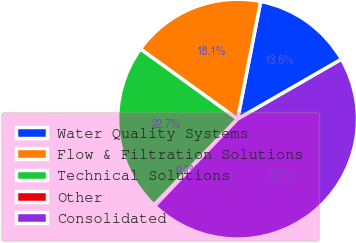<chart> <loc_0><loc_0><loc_500><loc_500><pie_chart><fcel>Water Quality Systems<fcel>Flow & Filtration Solutions<fcel>Technical Solutions<fcel>Other<fcel>Consolidated<nl><fcel>13.6%<fcel>18.13%<fcel>22.66%<fcel>0.16%<fcel>45.45%<nl></chart> 